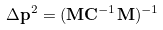Convert formula to latex. <formula><loc_0><loc_0><loc_500><loc_500>\Delta \mathbf p ^ { 2 } = ( \mathbf M \mathbf C ^ { - 1 } \mathbf M ) ^ { - 1 }</formula> 